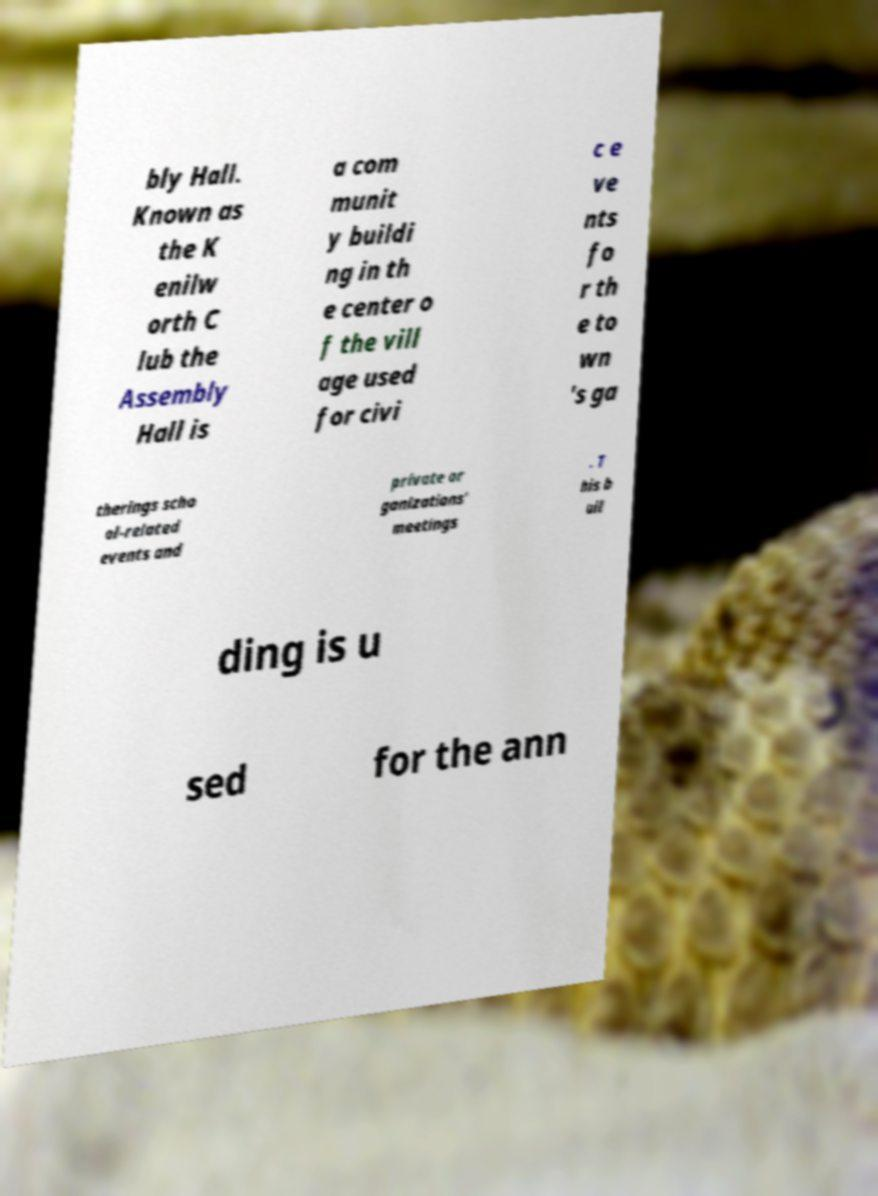Please identify and transcribe the text found in this image. bly Hall. Known as the K enilw orth C lub the Assembly Hall is a com munit y buildi ng in th e center o f the vill age used for civi c e ve nts fo r th e to wn 's ga therings scho ol-related events and private or ganizations' meetings . T his b uil ding is u sed for the ann 